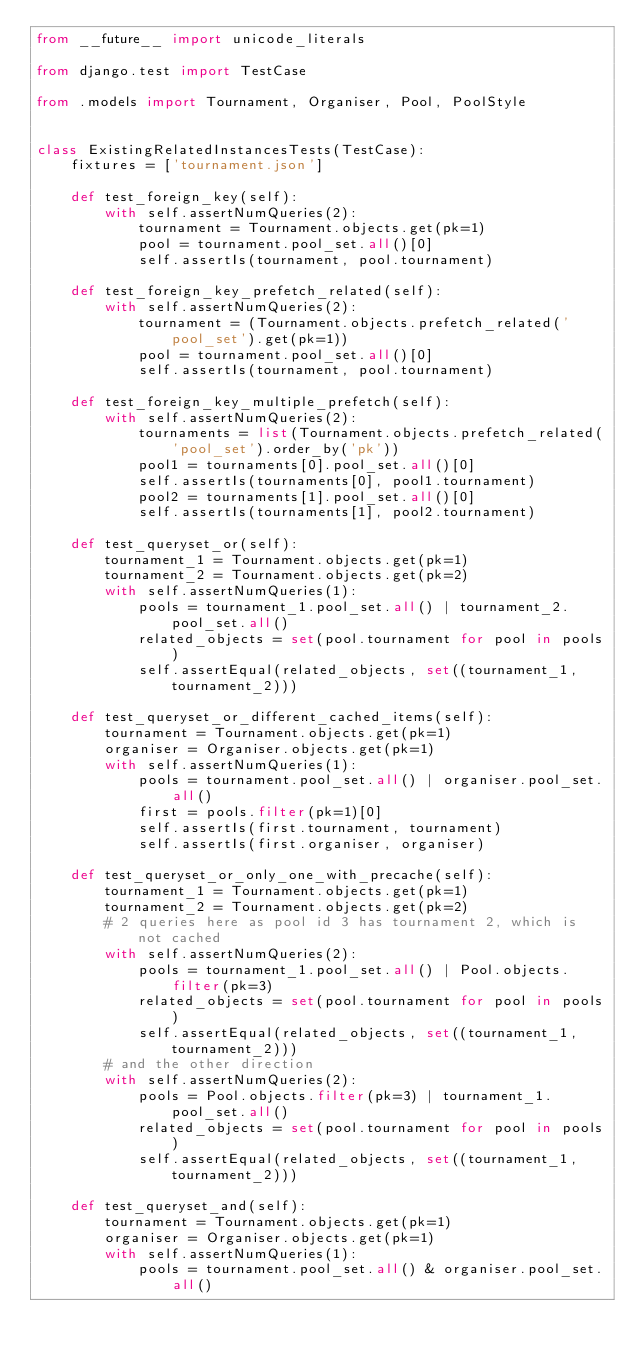Convert code to text. <code><loc_0><loc_0><loc_500><loc_500><_Python_>from __future__ import unicode_literals

from django.test import TestCase

from .models import Tournament, Organiser, Pool, PoolStyle


class ExistingRelatedInstancesTests(TestCase):
    fixtures = ['tournament.json']

    def test_foreign_key(self):
        with self.assertNumQueries(2):
            tournament = Tournament.objects.get(pk=1)
            pool = tournament.pool_set.all()[0]
            self.assertIs(tournament, pool.tournament)

    def test_foreign_key_prefetch_related(self):
        with self.assertNumQueries(2):
            tournament = (Tournament.objects.prefetch_related('pool_set').get(pk=1))
            pool = tournament.pool_set.all()[0]
            self.assertIs(tournament, pool.tournament)

    def test_foreign_key_multiple_prefetch(self):
        with self.assertNumQueries(2):
            tournaments = list(Tournament.objects.prefetch_related('pool_set').order_by('pk'))
            pool1 = tournaments[0].pool_set.all()[0]
            self.assertIs(tournaments[0], pool1.tournament)
            pool2 = tournaments[1].pool_set.all()[0]
            self.assertIs(tournaments[1], pool2.tournament)

    def test_queryset_or(self):
        tournament_1 = Tournament.objects.get(pk=1)
        tournament_2 = Tournament.objects.get(pk=2)
        with self.assertNumQueries(1):
            pools = tournament_1.pool_set.all() | tournament_2.pool_set.all()
            related_objects = set(pool.tournament for pool in pools)
            self.assertEqual(related_objects, set((tournament_1, tournament_2)))

    def test_queryset_or_different_cached_items(self):
        tournament = Tournament.objects.get(pk=1)
        organiser = Organiser.objects.get(pk=1)
        with self.assertNumQueries(1):
            pools = tournament.pool_set.all() | organiser.pool_set.all()
            first = pools.filter(pk=1)[0]
            self.assertIs(first.tournament, tournament)
            self.assertIs(first.organiser, organiser)

    def test_queryset_or_only_one_with_precache(self):
        tournament_1 = Tournament.objects.get(pk=1)
        tournament_2 = Tournament.objects.get(pk=2)
        # 2 queries here as pool id 3 has tournament 2, which is not cached
        with self.assertNumQueries(2):
            pools = tournament_1.pool_set.all() | Pool.objects.filter(pk=3)
            related_objects = set(pool.tournament for pool in pools)
            self.assertEqual(related_objects, set((tournament_1, tournament_2)))
        # and the other direction
        with self.assertNumQueries(2):
            pools = Pool.objects.filter(pk=3) | tournament_1.pool_set.all()
            related_objects = set(pool.tournament for pool in pools)
            self.assertEqual(related_objects, set((tournament_1, tournament_2)))

    def test_queryset_and(self):
        tournament = Tournament.objects.get(pk=1)
        organiser = Organiser.objects.get(pk=1)
        with self.assertNumQueries(1):
            pools = tournament.pool_set.all() & organiser.pool_set.all()</code> 